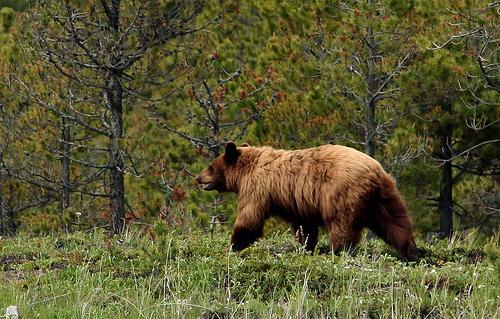Question: what animal is in the photo?
Choices:
A. A bear.
B. A panda.
C. A grizzly.
D. A koala.
Answer with the letter. Answer: A Question: where was this photo taken?
Choices:
A. In the forrest.
B. Outside.
C. Among the trees.
D. In the woods.
Answer with the letter. Answer: D Question: what colors are the leaves of the trees?
Choices:
A. Green and orange.
B. Red and blue.
C. Black and yellow.
D. Green and gold.
Answer with the letter. Answer: A Question: how large does the bear look?
Choices:
A. Very large.
B. Small.
C. Average.
D. Medium.
Answer with the letter. Answer: A Question: what color is the bear's fur?
Choices:
A. Black.
B. Brown.
C. White.
D. Red.
Answer with the letter. Answer: B Question: how many legs are the bear walking on?
Choices:
A. Three.
B. Two.
C. Four.
D. One.
Answer with the letter. Answer: C 